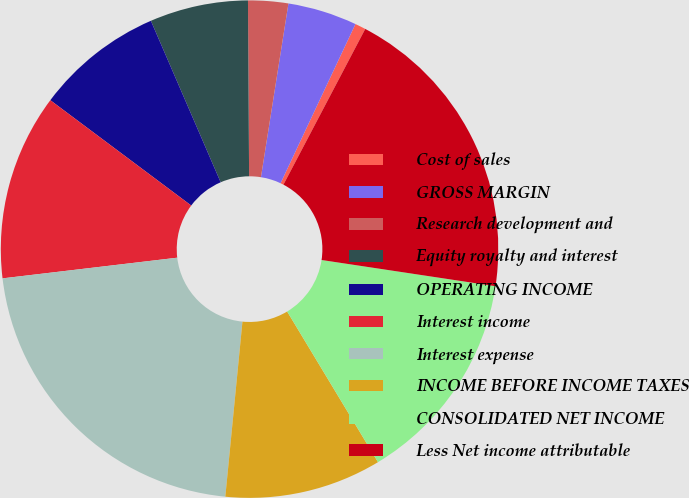Convert chart to OTSL. <chart><loc_0><loc_0><loc_500><loc_500><pie_chart><fcel>Cost of sales<fcel>GROSS MARGIN<fcel>Research development and<fcel>Equity royalty and interest<fcel>OPERATING INCOME<fcel>Interest income<fcel>Interest expense<fcel>INCOME BEFORE INCOME TAXES<fcel>CONSOLIDATED NET INCOME<fcel>Less Net income attributable<nl><fcel>0.7%<fcel>4.5%<fcel>2.6%<fcel>6.39%<fcel>8.29%<fcel>12.09%<fcel>21.57%<fcel>10.19%<fcel>13.98%<fcel>19.68%<nl></chart> 